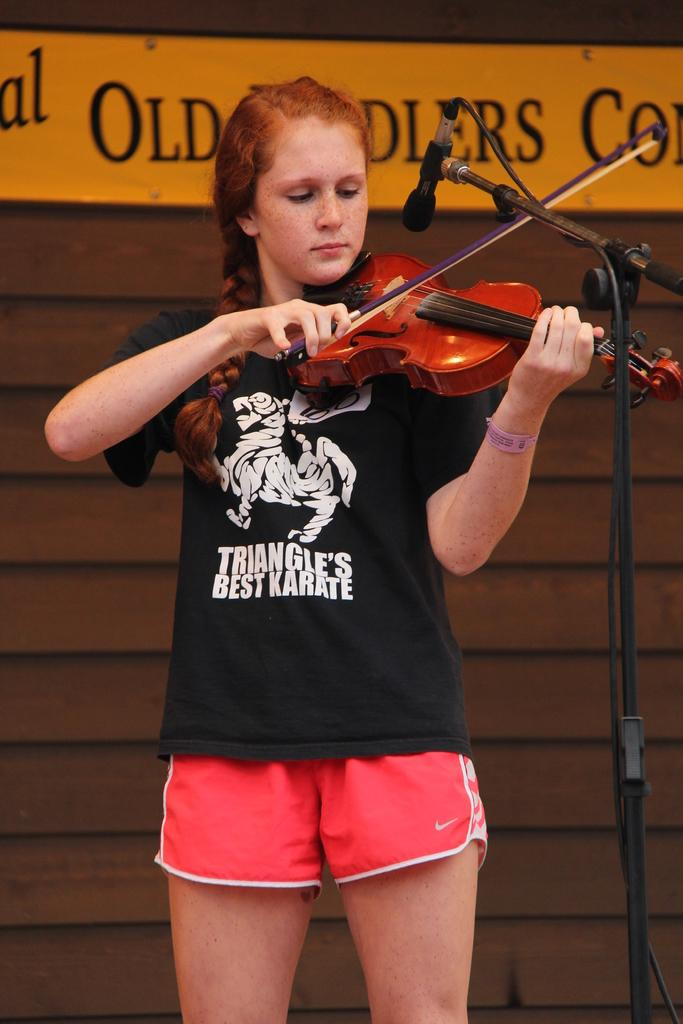Provide a one-sentence caption for the provided image. Girl wearing a shirt which says "Triangle's best karate" playing the violin. 